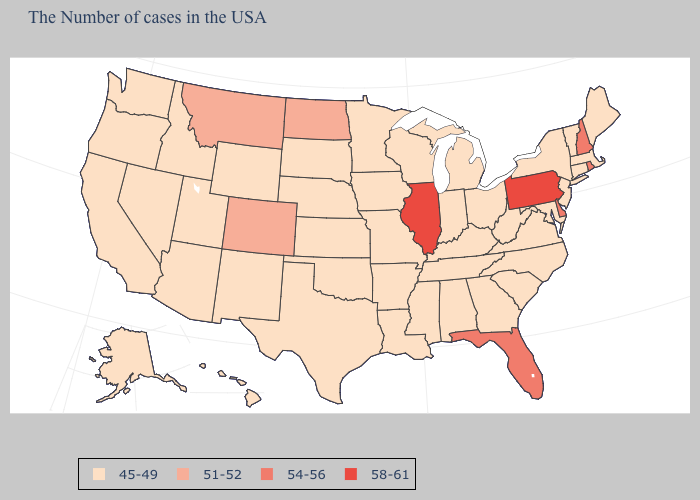Name the states that have a value in the range 58-61?
Be succinct. Pennsylvania, Illinois. Name the states that have a value in the range 51-52?
Short answer required. North Dakota, Colorado, Montana. What is the value of Hawaii?
Keep it brief. 45-49. Does Idaho have a lower value than Pennsylvania?
Write a very short answer. Yes. What is the lowest value in the South?
Short answer required. 45-49. What is the value of Louisiana?
Short answer required. 45-49. Does the map have missing data?
Keep it brief. No. What is the highest value in states that border Oregon?
Answer briefly. 45-49. What is the value of Utah?
Concise answer only. 45-49. Does Pennsylvania have the highest value in the Northeast?
Write a very short answer. Yes. Does Kentucky have the same value as Massachusetts?
Answer briefly. Yes. Name the states that have a value in the range 54-56?
Keep it brief. Rhode Island, New Hampshire, Delaware, Florida. Which states have the lowest value in the USA?
Keep it brief. Maine, Massachusetts, Vermont, Connecticut, New York, New Jersey, Maryland, Virginia, North Carolina, South Carolina, West Virginia, Ohio, Georgia, Michigan, Kentucky, Indiana, Alabama, Tennessee, Wisconsin, Mississippi, Louisiana, Missouri, Arkansas, Minnesota, Iowa, Kansas, Nebraska, Oklahoma, Texas, South Dakota, Wyoming, New Mexico, Utah, Arizona, Idaho, Nevada, California, Washington, Oregon, Alaska, Hawaii. Among the states that border Montana , does North Dakota have the lowest value?
Concise answer only. No. What is the lowest value in the MidWest?
Write a very short answer. 45-49. 